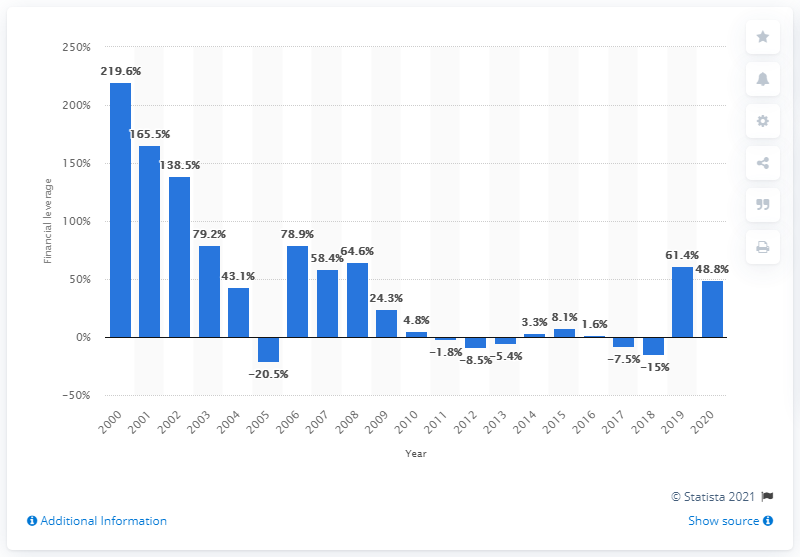List a handful of essential elements in this visual. The global financial leverage of Adidas Group in 2020 was 48.8. 